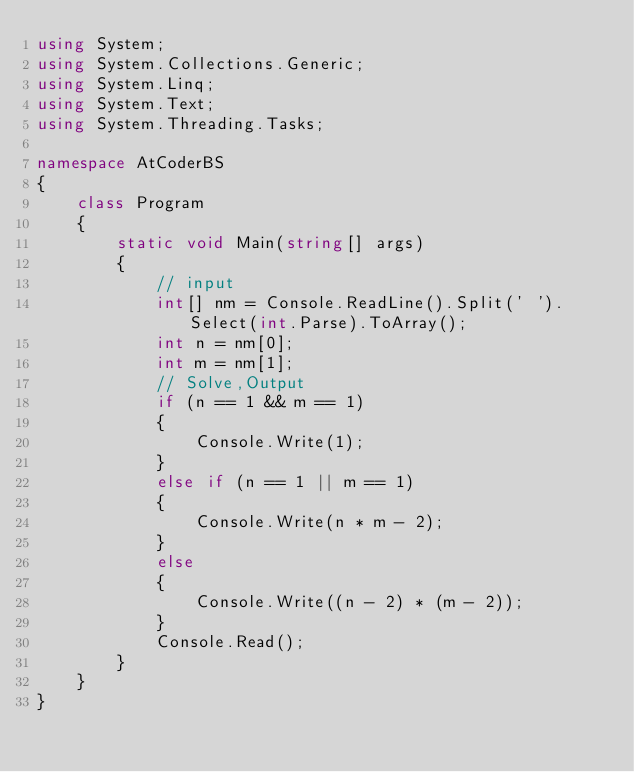Convert code to text. <code><loc_0><loc_0><loc_500><loc_500><_C#_>using System;
using System.Collections.Generic;
using System.Linq;
using System.Text;
using System.Threading.Tasks;

namespace AtCoderBS
{
    class Program
    {
        static void Main(string[] args)
        {
            // input
            int[] nm = Console.ReadLine().Split(' ').Select(int.Parse).ToArray();
            int n = nm[0];
            int m = nm[1];
            // Solve,Output
            if (n == 1 && m == 1)
            {
                Console.Write(1);
            }
            else if (n == 1 || m == 1)
            {
                Console.Write(n * m - 2);
            }
            else
            {
                Console.Write((n - 2) * (m - 2));
            }
            Console.Read();
        }
    }
}
</code> 